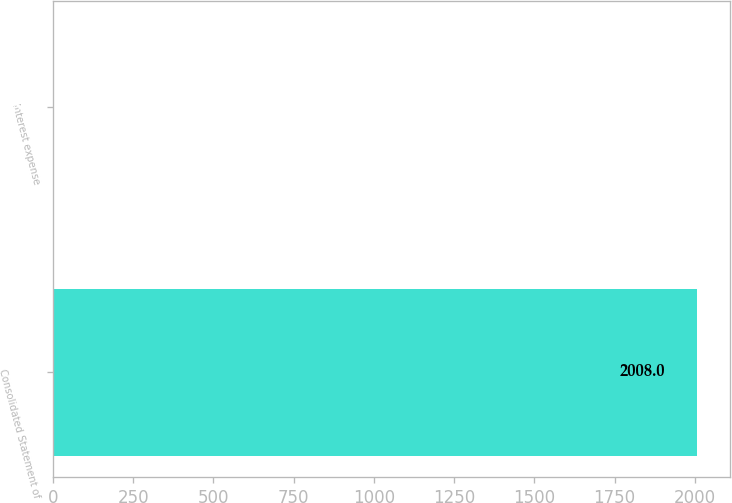Convert chart. <chart><loc_0><loc_0><loc_500><loc_500><bar_chart><fcel>Consolidated Statement of<fcel>Interest expense<nl><fcel>2008<fcel>3.8<nl></chart> 